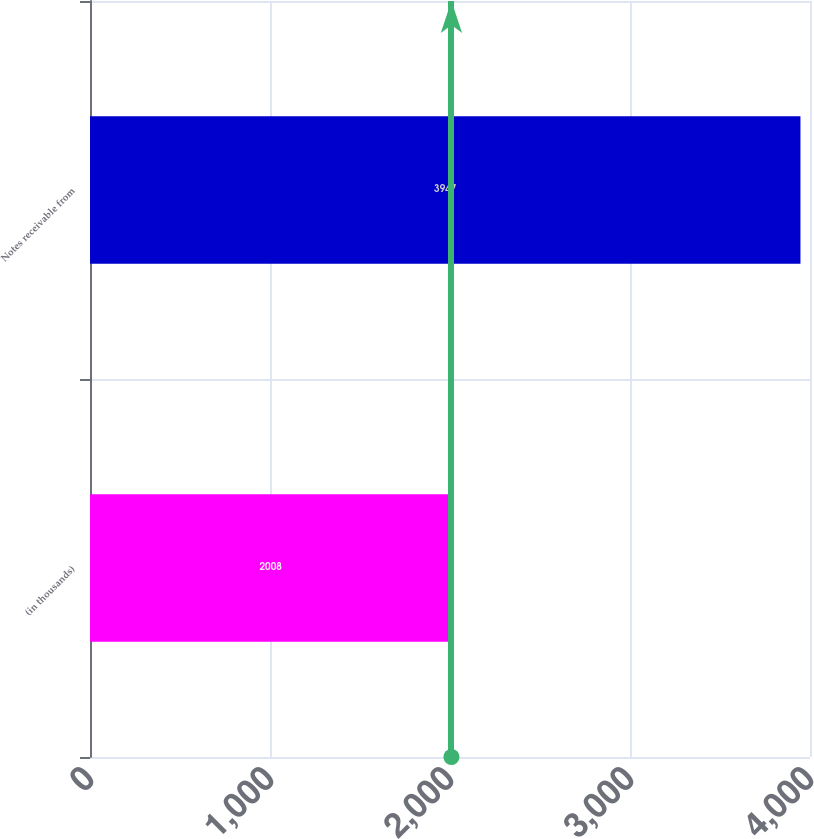Convert chart. <chart><loc_0><loc_0><loc_500><loc_500><bar_chart><fcel>(in thousands)<fcel>Notes receivable from<nl><fcel>2008<fcel>3947<nl></chart> 